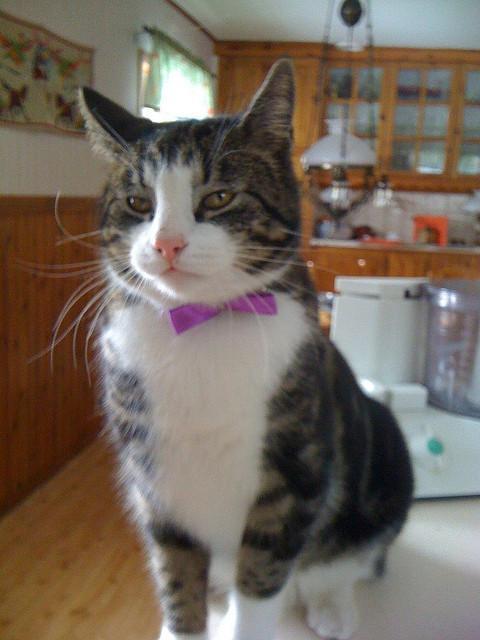How many computers?
Give a very brief answer. 0. 